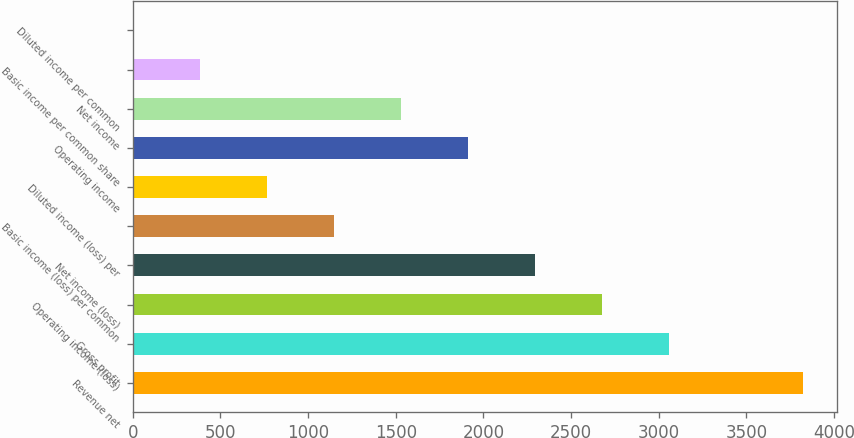Convert chart to OTSL. <chart><loc_0><loc_0><loc_500><loc_500><bar_chart><fcel>Revenue net<fcel>Gross profit<fcel>Operating income (loss)<fcel>Net income (loss)<fcel>Basic income (loss) per common<fcel>Diluted income (loss) per<fcel>Operating income<fcel>Net income<fcel>Basic income per common share<fcel>Diluted income per common<nl><fcel>3824<fcel>3059.33<fcel>2676.99<fcel>2294.65<fcel>1147.63<fcel>765.29<fcel>1912.31<fcel>1529.97<fcel>382.95<fcel>0.61<nl></chart> 